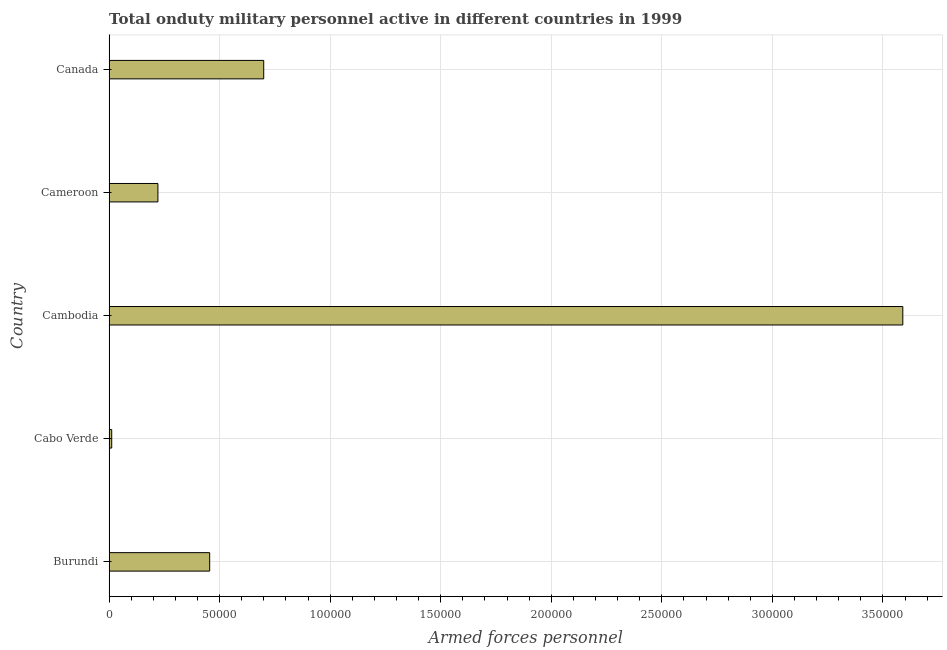Does the graph contain any zero values?
Provide a short and direct response. No. What is the title of the graph?
Offer a terse response. Total onduty military personnel active in different countries in 1999. What is the label or title of the X-axis?
Make the answer very short. Armed forces personnel. What is the label or title of the Y-axis?
Give a very brief answer. Country. What is the number of armed forces personnel in Canada?
Keep it short and to the point. 7.00e+04. Across all countries, what is the maximum number of armed forces personnel?
Offer a terse response. 3.59e+05. Across all countries, what is the minimum number of armed forces personnel?
Make the answer very short. 1200. In which country was the number of armed forces personnel maximum?
Provide a succinct answer. Cambodia. In which country was the number of armed forces personnel minimum?
Your response must be concise. Cabo Verde. What is the sum of the number of armed forces personnel?
Your answer should be compact. 4.98e+05. What is the difference between the number of armed forces personnel in Burundi and Cambodia?
Offer a very short reply. -3.14e+05. What is the average number of armed forces personnel per country?
Your response must be concise. 9.96e+04. What is the median number of armed forces personnel?
Keep it short and to the point. 4.55e+04. In how many countries, is the number of armed forces personnel greater than 210000 ?
Your answer should be very brief. 1. What is the ratio of the number of armed forces personnel in Cameroon to that in Canada?
Make the answer very short. 0.32. Is the number of armed forces personnel in Cambodia less than that in Canada?
Keep it short and to the point. No. What is the difference between the highest and the second highest number of armed forces personnel?
Offer a very short reply. 2.89e+05. What is the difference between the highest and the lowest number of armed forces personnel?
Give a very brief answer. 3.58e+05. How many bars are there?
Your response must be concise. 5. Are all the bars in the graph horizontal?
Keep it short and to the point. Yes. What is the difference between two consecutive major ticks on the X-axis?
Give a very brief answer. 5.00e+04. Are the values on the major ticks of X-axis written in scientific E-notation?
Offer a very short reply. No. What is the Armed forces personnel of Burundi?
Your response must be concise. 4.55e+04. What is the Armed forces personnel in Cabo Verde?
Give a very brief answer. 1200. What is the Armed forces personnel in Cambodia?
Offer a terse response. 3.59e+05. What is the Armed forces personnel in Cameroon?
Offer a very short reply. 2.21e+04. What is the Armed forces personnel in Canada?
Offer a very short reply. 7.00e+04. What is the difference between the Armed forces personnel in Burundi and Cabo Verde?
Provide a short and direct response. 4.43e+04. What is the difference between the Armed forces personnel in Burundi and Cambodia?
Provide a succinct answer. -3.14e+05. What is the difference between the Armed forces personnel in Burundi and Cameroon?
Your response must be concise. 2.34e+04. What is the difference between the Armed forces personnel in Burundi and Canada?
Keep it short and to the point. -2.44e+04. What is the difference between the Armed forces personnel in Cabo Verde and Cambodia?
Your answer should be very brief. -3.58e+05. What is the difference between the Armed forces personnel in Cabo Verde and Cameroon?
Your response must be concise. -2.09e+04. What is the difference between the Armed forces personnel in Cabo Verde and Canada?
Keep it short and to the point. -6.88e+04. What is the difference between the Armed forces personnel in Cambodia and Cameroon?
Your answer should be compact. 3.37e+05. What is the difference between the Armed forces personnel in Cambodia and Canada?
Provide a succinct answer. 2.89e+05. What is the difference between the Armed forces personnel in Cameroon and Canada?
Give a very brief answer. -4.78e+04. What is the ratio of the Armed forces personnel in Burundi to that in Cabo Verde?
Ensure brevity in your answer.  37.92. What is the ratio of the Armed forces personnel in Burundi to that in Cambodia?
Your answer should be very brief. 0.13. What is the ratio of the Armed forces personnel in Burundi to that in Cameroon?
Your answer should be compact. 2.06. What is the ratio of the Armed forces personnel in Burundi to that in Canada?
Give a very brief answer. 0.65. What is the ratio of the Armed forces personnel in Cabo Verde to that in Cambodia?
Your answer should be compact. 0. What is the ratio of the Armed forces personnel in Cabo Verde to that in Cameroon?
Offer a terse response. 0.05. What is the ratio of the Armed forces personnel in Cabo Verde to that in Canada?
Provide a succinct answer. 0.02. What is the ratio of the Armed forces personnel in Cambodia to that in Cameroon?
Give a very brief answer. 16.24. What is the ratio of the Armed forces personnel in Cambodia to that in Canada?
Ensure brevity in your answer.  5.13. What is the ratio of the Armed forces personnel in Cameroon to that in Canada?
Your answer should be compact. 0.32. 